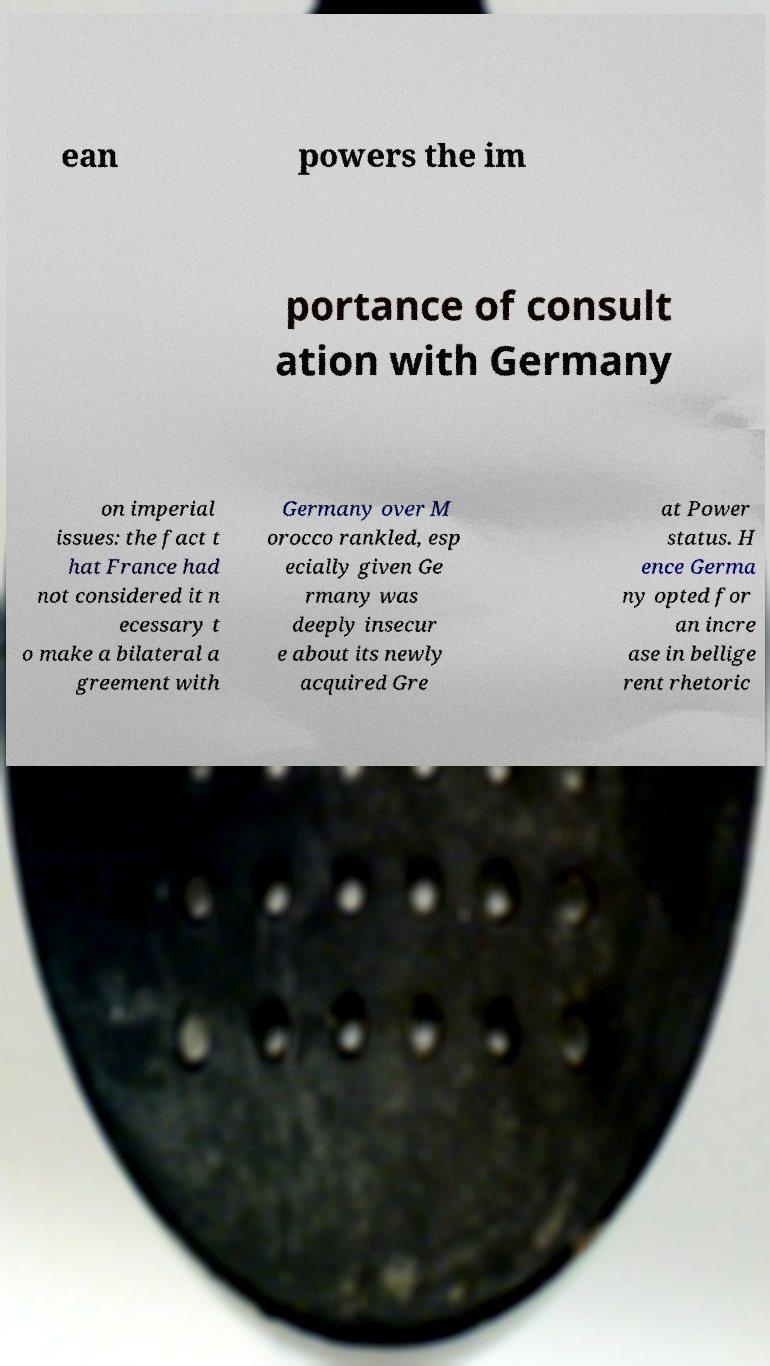Please identify and transcribe the text found in this image. ean powers the im portance of consult ation with Germany on imperial issues: the fact t hat France had not considered it n ecessary t o make a bilateral a greement with Germany over M orocco rankled, esp ecially given Ge rmany was deeply insecur e about its newly acquired Gre at Power status. H ence Germa ny opted for an incre ase in bellige rent rhetoric 